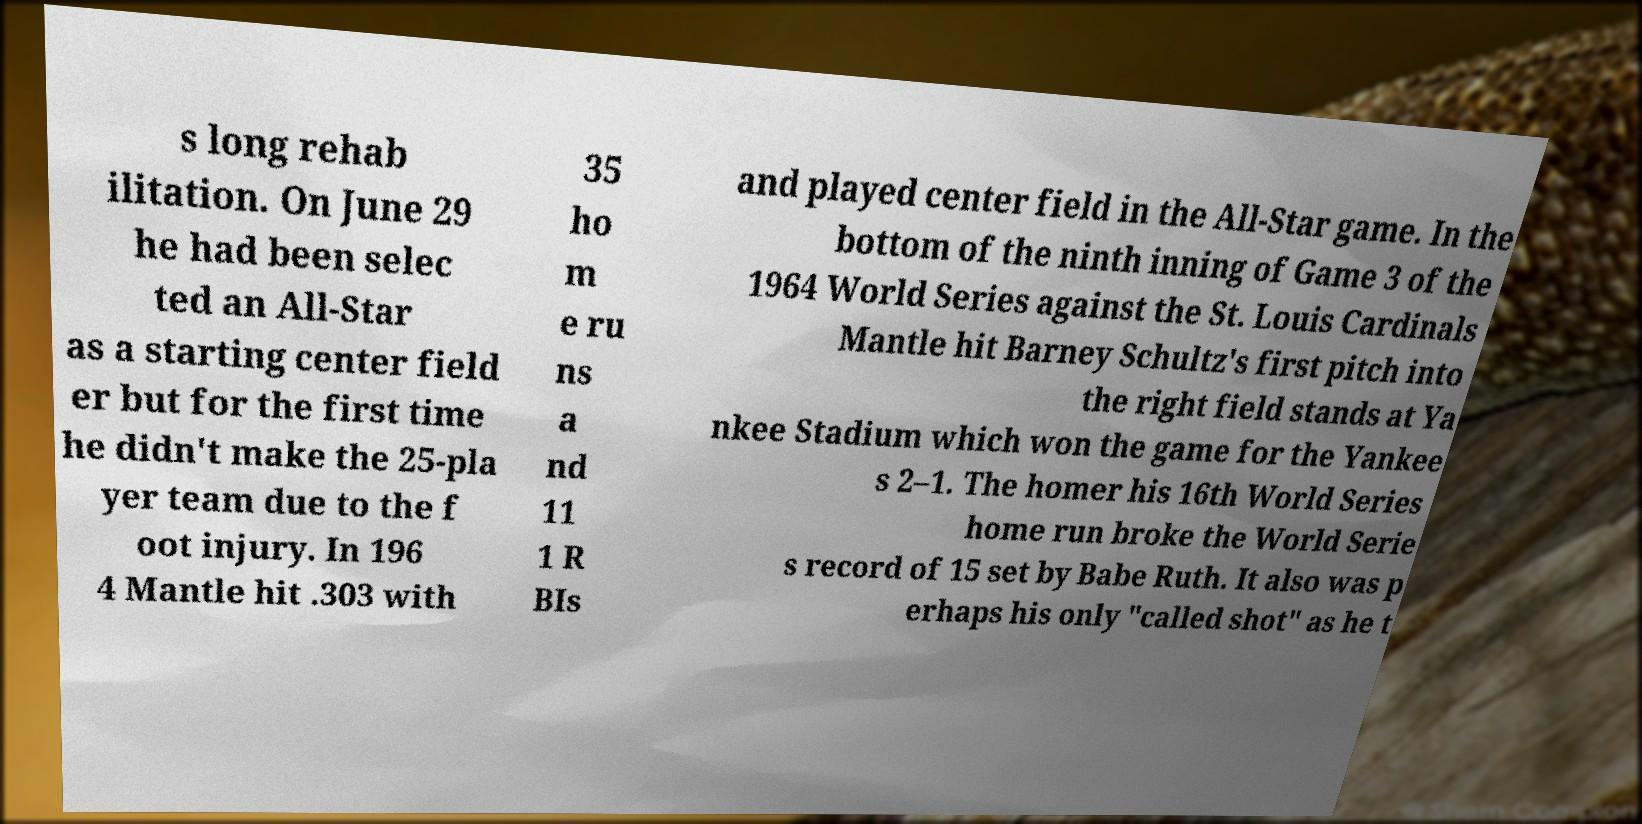Please read and relay the text visible in this image. What does it say? s long rehab ilitation. On June 29 he had been selec ted an All-Star as a starting center field er but for the first time he didn't make the 25-pla yer team due to the f oot injury. In 196 4 Mantle hit .303 with 35 ho m e ru ns a nd 11 1 R BIs and played center field in the All-Star game. In the bottom of the ninth inning of Game 3 of the 1964 World Series against the St. Louis Cardinals Mantle hit Barney Schultz's first pitch into the right field stands at Ya nkee Stadium which won the game for the Yankee s 2–1. The homer his 16th World Series home run broke the World Serie s record of 15 set by Babe Ruth. It also was p erhaps his only "called shot" as he t 